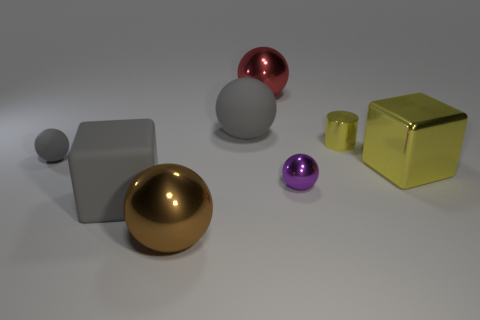What is the color of the object that is to the right of the small metallic cylinder that is to the right of the purple sphere?
Offer a very short reply. Yellow. There is a gray rubber ball in front of the big gray thing to the right of the large gray block; how big is it?
Your answer should be very brief. Small. What is the size of the shiny thing that is the same color as the small metallic cylinder?
Provide a succinct answer. Large. How many other things are there of the same size as the gray rubber cube?
Your response must be concise. 4. What is the color of the metallic sphere in front of the tiny ball that is right of the rubber cube that is in front of the big red sphere?
Offer a terse response. Brown. How many other objects are there of the same shape as the big red thing?
Your response must be concise. 4. There is a small shiny object that is in front of the yellow cube; what shape is it?
Give a very brief answer. Sphere. Is there a red metal ball that is in front of the big gray rubber object that is in front of the yellow metal cylinder?
Your response must be concise. No. The big ball that is behind the small purple thing and in front of the red shiny ball is what color?
Your answer should be very brief. Gray. Is there a thing that is left of the large yellow shiny cube that is behind the metal ball right of the big red sphere?
Make the answer very short. Yes. 